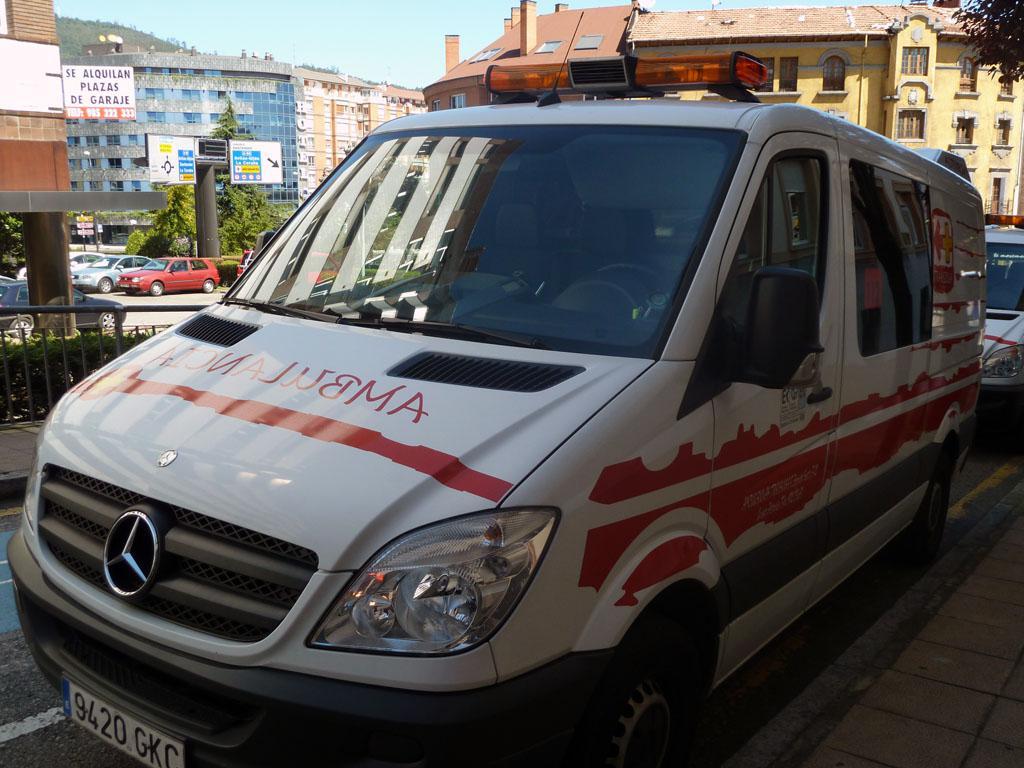What does the the text on the hood of the vehicle say?
Make the answer very short. Ambulance. What is the license plate number of the ambulance?
Your answer should be very brief. 9420 gkc. 